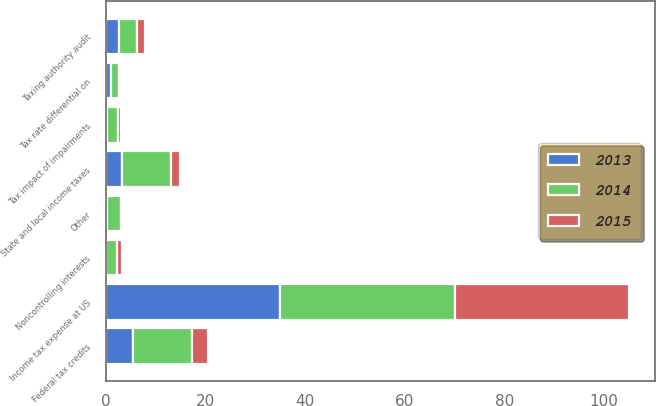Convert chart. <chart><loc_0><loc_0><loc_500><loc_500><stacked_bar_chart><ecel><fcel>Income tax expense at US<fcel>Federal tax credits<fcel>Taxing authority audit<fcel>Noncontrolling interests<fcel>State and local income taxes<fcel>Tax rate differential on<fcel>Tax impact of impairments<fcel>Other<nl><fcel>2013<fcel>35<fcel>5.49<fcel>2.67<fcel>0.04<fcel>3.2<fcel>0.99<fcel>0.23<fcel>0.13<nl><fcel>2015<fcel>35<fcel>3.21<fcel>1.59<fcel>0.81<fcel>1.77<fcel>0.46<fcel>0.46<fcel>0.34<nl><fcel>2014<fcel>35<fcel>11.74<fcel>3.56<fcel>2.28<fcel>9.81<fcel>1.63<fcel>2.28<fcel>2.94<nl></chart> 